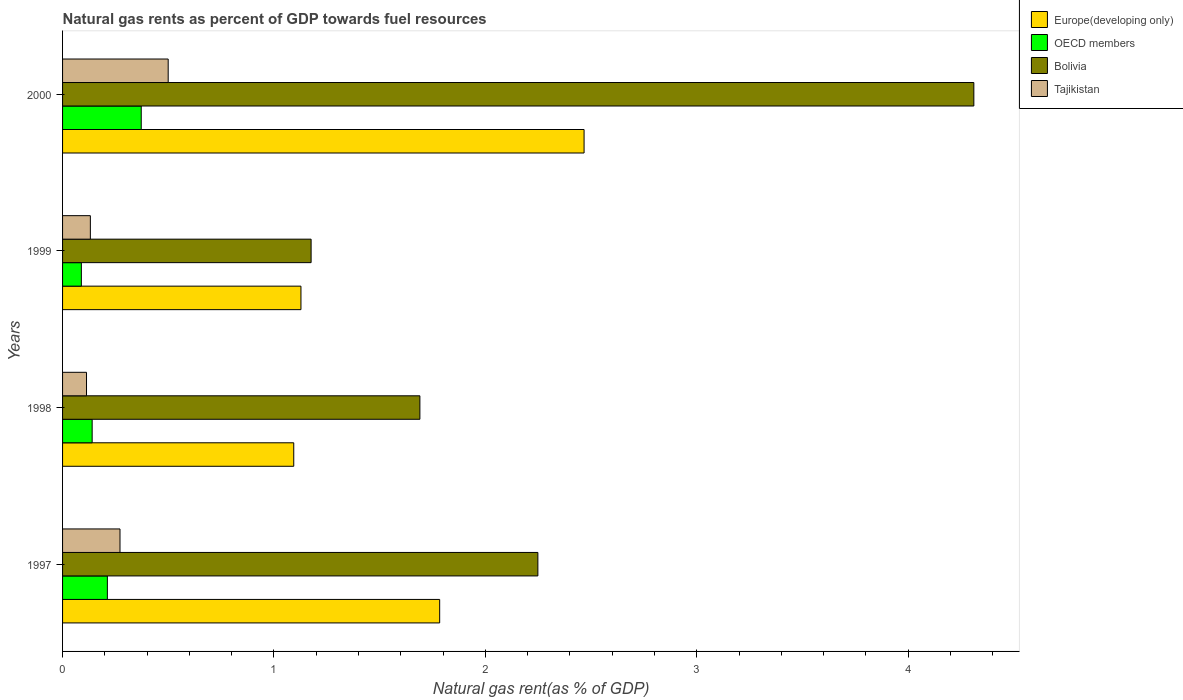How many bars are there on the 4th tick from the top?
Your answer should be compact. 4. What is the label of the 3rd group of bars from the top?
Your answer should be very brief. 1998. What is the natural gas rent in OECD members in 1999?
Keep it short and to the point. 0.09. Across all years, what is the maximum natural gas rent in Bolivia?
Offer a very short reply. 4.31. Across all years, what is the minimum natural gas rent in Bolivia?
Your response must be concise. 1.18. In which year was the natural gas rent in Europe(developing only) maximum?
Offer a terse response. 2000. In which year was the natural gas rent in Europe(developing only) minimum?
Provide a succinct answer. 1998. What is the total natural gas rent in OECD members in the graph?
Provide a succinct answer. 0.81. What is the difference between the natural gas rent in Tajikistan in 1998 and that in 2000?
Offer a very short reply. -0.39. What is the difference between the natural gas rent in Bolivia in 1998 and the natural gas rent in Europe(developing only) in 1999?
Make the answer very short. 0.56. What is the average natural gas rent in OECD members per year?
Your answer should be very brief. 0.2. In the year 1998, what is the difference between the natural gas rent in Europe(developing only) and natural gas rent in Tajikistan?
Offer a terse response. 0.98. In how many years, is the natural gas rent in Europe(developing only) greater than 3.2 %?
Give a very brief answer. 0. What is the ratio of the natural gas rent in Tajikistan in 1997 to that in 2000?
Provide a succinct answer. 0.54. Is the natural gas rent in Europe(developing only) in 1999 less than that in 2000?
Provide a short and direct response. Yes. Is the difference between the natural gas rent in Europe(developing only) in 1997 and 1999 greater than the difference between the natural gas rent in Tajikistan in 1997 and 1999?
Your response must be concise. Yes. What is the difference between the highest and the second highest natural gas rent in Bolivia?
Provide a short and direct response. 2.06. What is the difference between the highest and the lowest natural gas rent in Tajikistan?
Make the answer very short. 0.39. Is the sum of the natural gas rent in OECD members in 1997 and 2000 greater than the maximum natural gas rent in Europe(developing only) across all years?
Provide a succinct answer. No. What does the 4th bar from the top in 1999 represents?
Provide a short and direct response. Europe(developing only). What does the 4th bar from the bottom in 2000 represents?
Keep it short and to the point. Tajikistan. Are all the bars in the graph horizontal?
Make the answer very short. Yes. How many years are there in the graph?
Offer a terse response. 4. Does the graph contain grids?
Give a very brief answer. No. Where does the legend appear in the graph?
Your answer should be very brief. Top right. How many legend labels are there?
Offer a terse response. 4. What is the title of the graph?
Make the answer very short. Natural gas rents as percent of GDP towards fuel resources. Does "Spain" appear as one of the legend labels in the graph?
Your response must be concise. No. What is the label or title of the X-axis?
Offer a very short reply. Natural gas rent(as % of GDP). What is the Natural gas rent(as % of GDP) of Europe(developing only) in 1997?
Ensure brevity in your answer.  1.78. What is the Natural gas rent(as % of GDP) of OECD members in 1997?
Ensure brevity in your answer.  0.21. What is the Natural gas rent(as % of GDP) in Bolivia in 1997?
Offer a terse response. 2.25. What is the Natural gas rent(as % of GDP) of Tajikistan in 1997?
Your answer should be compact. 0.27. What is the Natural gas rent(as % of GDP) of Europe(developing only) in 1998?
Your response must be concise. 1.09. What is the Natural gas rent(as % of GDP) in OECD members in 1998?
Offer a terse response. 0.14. What is the Natural gas rent(as % of GDP) of Bolivia in 1998?
Offer a terse response. 1.69. What is the Natural gas rent(as % of GDP) in Tajikistan in 1998?
Give a very brief answer. 0.11. What is the Natural gas rent(as % of GDP) in Europe(developing only) in 1999?
Give a very brief answer. 1.13. What is the Natural gas rent(as % of GDP) of OECD members in 1999?
Provide a short and direct response. 0.09. What is the Natural gas rent(as % of GDP) in Bolivia in 1999?
Keep it short and to the point. 1.18. What is the Natural gas rent(as % of GDP) of Tajikistan in 1999?
Your response must be concise. 0.13. What is the Natural gas rent(as % of GDP) of Europe(developing only) in 2000?
Provide a succinct answer. 2.47. What is the Natural gas rent(as % of GDP) of OECD members in 2000?
Ensure brevity in your answer.  0.37. What is the Natural gas rent(as % of GDP) of Bolivia in 2000?
Provide a short and direct response. 4.31. What is the Natural gas rent(as % of GDP) in Tajikistan in 2000?
Keep it short and to the point. 0.5. Across all years, what is the maximum Natural gas rent(as % of GDP) in Europe(developing only)?
Ensure brevity in your answer.  2.47. Across all years, what is the maximum Natural gas rent(as % of GDP) in OECD members?
Provide a short and direct response. 0.37. Across all years, what is the maximum Natural gas rent(as % of GDP) of Bolivia?
Ensure brevity in your answer.  4.31. Across all years, what is the maximum Natural gas rent(as % of GDP) of Tajikistan?
Make the answer very short. 0.5. Across all years, what is the minimum Natural gas rent(as % of GDP) of Europe(developing only)?
Your answer should be very brief. 1.09. Across all years, what is the minimum Natural gas rent(as % of GDP) of OECD members?
Provide a short and direct response. 0.09. Across all years, what is the minimum Natural gas rent(as % of GDP) of Bolivia?
Your answer should be compact. 1.18. Across all years, what is the minimum Natural gas rent(as % of GDP) in Tajikistan?
Ensure brevity in your answer.  0.11. What is the total Natural gas rent(as % of GDP) in Europe(developing only) in the graph?
Keep it short and to the point. 6.47. What is the total Natural gas rent(as % of GDP) in OECD members in the graph?
Make the answer very short. 0.81. What is the total Natural gas rent(as % of GDP) of Bolivia in the graph?
Ensure brevity in your answer.  9.42. What is the total Natural gas rent(as % of GDP) of Tajikistan in the graph?
Give a very brief answer. 1.02. What is the difference between the Natural gas rent(as % of GDP) of Europe(developing only) in 1997 and that in 1998?
Offer a terse response. 0.69. What is the difference between the Natural gas rent(as % of GDP) of OECD members in 1997 and that in 1998?
Offer a very short reply. 0.07. What is the difference between the Natural gas rent(as % of GDP) in Bolivia in 1997 and that in 1998?
Provide a short and direct response. 0.56. What is the difference between the Natural gas rent(as % of GDP) in Tajikistan in 1997 and that in 1998?
Provide a short and direct response. 0.16. What is the difference between the Natural gas rent(as % of GDP) in Europe(developing only) in 1997 and that in 1999?
Provide a succinct answer. 0.66. What is the difference between the Natural gas rent(as % of GDP) of OECD members in 1997 and that in 1999?
Ensure brevity in your answer.  0.12. What is the difference between the Natural gas rent(as % of GDP) in Bolivia in 1997 and that in 1999?
Make the answer very short. 1.07. What is the difference between the Natural gas rent(as % of GDP) of Tajikistan in 1997 and that in 1999?
Offer a terse response. 0.14. What is the difference between the Natural gas rent(as % of GDP) of Europe(developing only) in 1997 and that in 2000?
Your answer should be compact. -0.68. What is the difference between the Natural gas rent(as % of GDP) of OECD members in 1997 and that in 2000?
Provide a short and direct response. -0.16. What is the difference between the Natural gas rent(as % of GDP) of Bolivia in 1997 and that in 2000?
Your answer should be compact. -2.06. What is the difference between the Natural gas rent(as % of GDP) in Tajikistan in 1997 and that in 2000?
Keep it short and to the point. -0.23. What is the difference between the Natural gas rent(as % of GDP) in Europe(developing only) in 1998 and that in 1999?
Provide a succinct answer. -0.03. What is the difference between the Natural gas rent(as % of GDP) in OECD members in 1998 and that in 1999?
Offer a very short reply. 0.05. What is the difference between the Natural gas rent(as % of GDP) in Bolivia in 1998 and that in 1999?
Offer a very short reply. 0.51. What is the difference between the Natural gas rent(as % of GDP) in Tajikistan in 1998 and that in 1999?
Your response must be concise. -0.02. What is the difference between the Natural gas rent(as % of GDP) in Europe(developing only) in 1998 and that in 2000?
Provide a succinct answer. -1.37. What is the difference between the Natural gas rent(as % of GDP) in OECD members in 1998 and that in 2000?
Your answer should be very brief. -0.23. What is the difference between the Natural gas rent(as % of GDP) in Bolivia in 1998 and that in 2000?
Your answer should be compact. -2.62. What is the difference between the Natural gas rent(as % of GDP) in Tajikistan in 1998 and that in 2000?
Your answer should be compact. -0.39. What is the difference between the Natural gas rent(as % of GDP) of Europe(developing only) in 1999 and that in 2000?
Offer a very short reply. -1.34. What is the difference between the Natural gas rent(as % of GDP) of OECD members in 1999 and that in 2000?
Offer a very short reply. -0.28. What is the difference between the Natural gas rent(as % of GDP) of Bolivia in 1999 and that in 2000?
Your answer should be very brief. -3.13. What is the difference between the Natural gas rent(as % of GDP) in Tajikistan in 1999 and that in 2000?
Offer a very short reply. -0.37. What is the difference between the Natural gas rent(as % of GDP) of Europe(developing only) in 1997 and the Natural gas rent(as % of GDP) of OECD members in 1998?
Your answer should be very brief. 1.64. What is the difference between the Natural gas rent(as % of GDP) of Europe(developing only) in 1997 and the Natural gas rent(as % of GDP) of Bolivia in 1998?
Make the answer very short. 0.09. What is the difference between the Natural gas rent(as % of GDP) in Europe(developing only) in 1997 and the Natural gas rent(as % of GDP) in Tajikistan in 1998?
Your answer should be very brief. 1.67. What is the difference between the Natural gas rent(as % of GDP) in OECD members in 1997 and the Natural gas rent(as % of GDP) in Bolivia in 1998?
Ensure brevity in your answer.  -1.48. What is the difference between the Natural gas rent(as % of GDP) in OECD members in 1997 and the Natural gas rent(as % of GDP) in Tajikistan in 1998?
Your response must be concise. 0.1. What is the difference between the Natural gas rent(as % of GDP) of Bolivia in 1997 and the Natural gas rent(as % of GDP) of Tajikistan in 1998?
Keep it short and to the point. 2.14. What is the difference between the Natural gas rent(as % of GDP) in Europe(developing only) in 1997 and the Natural gas rent(as % of GDP) in OECD members in 1999?
Offer a terse response. 1.7. What is the difference between the Natural gas rent(as % of GDP) of Europe(developing only) in 1997 and the Natural gas rent(as % of GDP) of Bolivia in 1999?
Keep it short and to the point. 0.61. What is the difference between the Natural gas rent(as % of GDP) in Europe(developing only) in 1997 and the Natural gas rent(as % of GDP) in Tajikistan in 1999?
Give a very brief answer. 1.65. What is the difference between the Natural gas rent(as % of GDP) of OECD members in 1997 and the Natural gas rent(as % of GDP) of Bolivia in 1999?
Your answer should be compact. -0.96. What is the difference between the Natural gas rent(as % of GDP) in OECD members in 1997 and the Natural gas rent(as % of GDP) in Tajikistan in 1999?
Keep it short and to the point. 0.08. What is the difference between the Natural gas rent(as % of GDP) in Bolivia in 1997 and the Natural gas rent(as % of GDP) in Tajikistan in 1999?
Your response must be concise. 2.12. What is the difference between the Natural gas rent(as % of GDP) of Europe(developing only) in 1997 and the Natural gas rent(as % of GDP) of OECD members in 2000?
Ensure brevity in your answer.  1.41. What is the difference between the Natural gas rent(as % of GDP) in Europe(developing only) in 1997 and the Natural gas rent(as % of GDP) in Bolivia in 2000?
Provide a succinct answer. -2.53. What is the difference between the Natural gas rent(as % of GDP) of Europe(developing only) in 1997 and the Natural gas rent(as % of GDP) of Tajikistan in 2000?
Your response must be concise. 1.28. What is the difference between the Natural gas rent(as % of GDP) of OECD members in 1997 and the Natural gas rent(as % of GDP) of Bolivia in 2000?
Provide a short and direct response. -4.1. What is the difference between the Natural gas rent(as % of GDP) of OECD members in 1997 and the Natural gas rent(as % of GDP) of Tajikistan in 2000?
Provide a short and direct response. -0.29. What is the difference between the Natural gas rent(as % of GDP) in Bolivia in 1997 and the Natural gas rent(as % of GDP) in Tajikistan in 2000?
Give a very brief answer. 1.75. What is the difference between the Natural gas rent(as % of GDP) in Europe(developing only) in 1998 and the Natural gas rent(as % of GDP) in OECD members in 1999?
Your answer should be very brief. 1. What is the difference between the Natural gas rent(as % of GDP) of Europe(developing only) in 1998 and the Natural gas rent(as % of GDP) of Bolivia in 1999?
Give a very brief answer. -0.08. What is the difference between the Natural gas rent(as % of GDP) in Europe(developing only) in 1998 and the Natural gas rent(as % of GDP) in Tajikistan in 1999?
Keep it short and to the point. 0.96. What is the difference between the Natural gas rent(as % of GDP) in OECD members in 1998 and the Natural gas rent(as % of GDP) in Bolivia in 1999?
Your response must be concise. -1.04. What is the difference between the Natural gas rent(as % of GDP) of OECD members in 1998 and the Natural gas rent(as % of GDP) of Tajikistan in 1999?
Provide a short and direct response. 0.01. What is the difference between the Natural gas rent(as % of GDP) of Bolivia in 1998 and the Natural gas rent(as % of GDP) of Tajikistan in 1999?
Your response must be concise. 1.56. What is the difference between the Natural gas rent(as % of GDP) in Europe(developing only) in 1998 and the Natural gas rent(as % of GDP) in OECD members in 2000?
Offer a terse response. 0.72. What is the difference between the Natural gas rent(as % of GDP) in Europe(developing only) in 1998 and the Natural gas rent(as % of GDP) in Bolivia in 2000?
Your response must be concise. -3.22. What is the difference between the Natural gas rent(as % of GDP) in Europe(developing only) in 1998 and the Natural gas rent(as % of GDP) in Tajikistan in 2000?
Give a very brief answer. 0.59. What is the difference between the Natural gas rent(as % of GDP) of OECD members in 1998 and the Natural gas rent(as % of GDP) of Bolivia in 2000?
Ensure brevity in your answer.  -4.17. What is the difference between the Natural gas rent(as % of GDP) in OECD members in 1998 and the Natural gas rent(as % of GDP) in Tajikistan in 2000?
Provide a short and direct response. -0.36. What is the difference between the Natural gas rent(as % of GDP) in Bolivia in 1998 and the Natural gas rent(as % of GDP) in Tajikistan in 2000?
Offer a very short reply. 1.19. What is the difference between the Natural gas rent(as % of GDP) in Europe(developing only) in 1999 and the Natural gas rent(as % of GDP) in OECD members in 2000?
Offer a very short reply. 0.76. What is the difference between the Natural gas rent(as % of GDP) of Europe(developing only) in 1999 and the Natural gas rent(as % of GDP) of Bolivia in 2000?
Offer a terse response. -3.18. What is the difference between the Natural gas rent(as % of GDP) of Europe(developing only) in 1999 and the Natural gas rent(as % of GDP) of Tajikistan in 2000?
Offer a very short reply. 0.63. What is the difference between the Natural gas rent(as % of GDP) of OECD members in 1999 and the Natural gas rent(as % of GDP) of Bolivia in 2000?
Offer a very short reply. -4.22. What is the difference between the Natural gas rent(as % of GDP) of OECD members in 1999 and the Natural gas rent(as % of GDP) of Tajikistan in 2000?
Provide a short and direct response. -0.41. What is the difference between the Natural gas rent(as % of GDP) in Bolivia in 1999 and the Natural gas rent(as % of GDP) in Tajikistan in 2000?
Provide a succinct answer. 0.68. What is the average Natural gas rent(as % of GDP) in Europe(developing only) per year?
Keep it short and to the point. 1.62. What is the average Natural gas rent(as % of GDP) in OECD members per year?
Keep it short and to the point. 0.2. What is the average Natural gas rent(as % of GDP) of Bolivia per year?
Your answer should be compact. 2.36. What is the average Natural gas rent(as % of GDP) of Tajikistan per year?
Provide a short and direct response. 0.25. In the year 1997, what is the difference between the Natural gas rent(as % of GDP) of Europe(developing only) and Natural gas rent(as % of GDP) of OECD members?
Make the answer very short. 1.57. In the year 1997, what is the difference between the Natural gas rent(as % of GDP) in Europe(developing only) and Natural gas rent(as % of GDP) in Bolivia?
Your answer should be compact. -0.46. In the year 1997, what is the difference between the Natural gas rent(as % of GDP) in Europe(developing only) and Natural gas rent(as % of GDP) in Tajikistan?
Make the answer very short. 1.51. In the year 1997, what is the difference between the Natural gas rent(as % of GDP) of OECD members and Natural gas rent(as % of GDP) of Bolivia?
Your answer should be very brief. -2.04. In the year 1997, what is the difference between the Natural gas rent(as % of GDP) in OECD members and Natural gas rent(as % of GDP) in Tajikistan?
Your answer should be compact. -0.06. In the year 1997, what is the difference between the Natural gas rent(as % of GDP) in Bolivia and Natural gas rent(as % of GDP) in Tajikistan?
Give a very brief answer. 1.98. In the year 1998, what is the difference between the Natural gas rent(as % of GDP) in Europe(developing only) and Natural gas rent(as % of GDP) in OECD members?
Offer a terse response. 0.95. In the year 1998, what is the difference between the Natural gas rent(as % of GDP) in Europe(developing only) and Natural gas rent(as % of GDP) in Bolivia?
Your answer should be compact. -0.6. In the year 1998, what is the difference between the Natural gas rent(as % of GDP) of Europe(developing only) and Natural gas rent(as % of GDP) of Tajikistan?
Offer a terse response. 0.98. In the year 1998, what is the difference between the Natural gas rent(as % of GDP) of OECD members and Natural gas rent(as % of GDP) of Bolivia?
Offer a terse response. -1.55. In the year 1998, what is the difference between the Natural gas rent(as % of GDP) in OECD members and Natural gas rent(as % of GDP) in Tajikistan?
Your answer should be very brief. 0.03. In the year 1998, what is the difference between the Natural gas rent(as % of GDP) of Bolivia and Natural gas rent(as % of GDP) of Tajikistan?
Your answer should be very brief. 1.58. In the year 1999, what is the difference between the Natural gas rent(as % of GDP) in Europe(developing only) and Natural gas rent(as % of GDP) in OECD members?
Provide a succinct answer. 1.04. In the year 1999, what is the difference between the Natural gas rent(as % of GDP) of Europe(developing only) and Natural gas rent(as % of GDP) of Bolivia?
Offer a terse response. -0.05. In the year 1999, what is the difference between the Natural gas rent(as % of GDP) of Europe(developing only) and Natural gas rent(as % of GDP) of Tajikistan?
Ensure brevity in your answer.  1. In the year 1999, what is the difference between the Natural gas rent(as % of GDP) of OECD members and Natural gas rent(as % of GDP) of Bolivia?
Keep it short and to the point. -1.09. In the year 1999, what is the difference between the Natural gas rent(as % of GDP) of OECD members and Natural gas rent(as % of GDP) of Tajikistan?
Give a very brief answer. -0.04. In the year 1999, what is the difference between the Natural gas rent(as % of GDP) in Bolivia and Natural gas rent(as % of GDP) in Tajikistan?
Your answer should be compact. 1.04. In the year 2000, what is the difference between the Natural gas rent(as % of GDP) in Europe(developing only) and Natural gas rent(as % of GDP) in OECD members?
Keep it short and to the point. 2.09. In the year 2000, what is the difference between the Natural gas rent(as % of GDP) in Europe(developing only) and Natural gas rent(as % of GDP) in Bolivia?
Provide a succinct answer. -1.84. In the year 2000, what is the difference between the Natural gas rent(as % of GDP) in Europe(developing only) and Natural gas rent(as % of GDP) in Tajikistan?
Your response must be concise. 1.97. In the year 2000, what is the difference between the Natural gas rent(as % of GDP) of OECD members and Natural gas rent(as % of GDP) of Bolivia?
Make the answer very short. -3.94. In the year 2000, what is the difference between the Natural gas rent(as % of GDP) in OECD members and Natural gas rent(as % of GDP) in Tajikistan?
Offer a terse response. -0.13. In the year 2000, what is the difference between the Natural gas rent(as % of GDP) in Bolivia and Natural gas rent(as % of GDP) in Tajikistan?
Your answer should be compact. 3.81. What is the ratio of the Natural gas rent(as % of GDP) of Europe(developing only) in 1997 to that in 1998?
Offer a terse response. 1.63. What is the ratio of the Natural gas rent(as % of GDP) in OECD members in 1997 to that in 1998?
Make the answer very short. 1.51. What is the ratio of the Natural gas rent(as % of GDP) of Bolivia in 1997 to that in 1998?
Your answer should be very brief. 1.33. What is the ratio of the Natural gas rent(as % of GDP) in Tajikistan in 1997 to that in 1998?
Offer a very short reply. 2.4. What is the ratio of the Natural gas rent(as % of GDP) of Europe(developing only) in 1997 to that in 1999?
Provide a short and direct response. 1.58. What is the ratio of the Natural gas rent(as % of GDP) in OECD members in 1997 to that in 1999?
Your answer should be compact. 2.38. What is the ratio of the Natural gas rent(as % of GDP) of Bolivia in 1997 to that in 1999?
Provide a short and direct response. 1.91. What is the ratio of the Natural gas rent(as % of GDP) in Tajikistan in 1997 to that in 1999?
Provide a succinct answer. 2.07. What is the ratio of the Natural gas rent(as % of GDP) in Europe(developing only) in 1997 to that in 2000?
Your response must be concise. 0.72. What is the ratio of the Natural gas rent(as % of GDP) in OECD members in 1997 to that in 2000?
Keep it short and to the point. 0.57. What is the ratio of the Natural gas rent(as % of GDP) of Bolivia in 1997 to that in 2000?
Your answer should be very brief. 0.52. What is the ratio of the Natural gas rent(as % of GDP) in Tajikistan in 1997 to that in 2000?
Offer a terse response. 0.54. What is the ratio of the Natural gas rent(as % of GDP) in Europe(developing only) in 1998 to that in 1999?
Your response must be concise. 0.97. What is the ratio of the Natural gas rent(as % of GDP) of OECD members in 1998 to that in 1999?
Give a very brief answer. 1.57. What is the ratio of the Natural gas rent(as % of GDP) of Bolivia in 1998 to that in 1999?
Ensure brevity in your answer.  1.44. What is the ratio of the Natural gas rent(as % of GDP) in Tajikistan in 1998 to that in 1999?
Keep it short and to the point. 0.86. What is the ratio of the Natural gas rent(as % of GDP) of Europe(developing only) in 1998 to that in 2000?
Make the answer very short. 0.44. What is the ratio of the Natural gas rent(as % of GDP) of OECD members in 1998 to that in 2000?
Offer a very short reply. 0.38. What is the ratio of the Natural gas rent(as % of GDP) of Bolivia in 1998 to that in 2000?
Offer a terse response. 0.39. What is the ratio of the Natural gas rent(as % of GDP) of Tajikistan in 1998 to that in 2000?
Ensure brevity in your answer.  0.23. What is the ratio of the Natural gas rent(as % of GDP) in Europe(developing only) in 1999 to that in 2000?
Offer a very short reply. 0.46. What is the ratio of the Natural gas rent(as % of GDP) in OECD members in 1999 to that in 2000?
Provide a succinct answer. 0.24. What is the ratio of the Natural gas rent(as % of GDP) of Bolivia in 1999 to that in 2000?
Your response must be concise. 0.27. What is the ratio of the Natural gas rent(as % of GDP) in Tajikistan in 1999 to that in 2000?
Your answer should be very brief. 0.26. What is the difference between the highest and the second highest Natural gas rent(as % of GDP) in Europe(developing only)?
Offer a terse response. 0.68. What is the difference between the highest and the second highest Natural gas rent(as % of GDP) of OECD members?
Give a very brief answer. 0.16. What is the difference between the highest and the second highest Natural gas rent(as % of GDP) of Bolivia?
Make the answer very short. 2.06. What is the difference between the highest and the second highest Natural gas rent(as % of GDP) in Tajikistan?
Provide a succinct answer. 0.23. What is the difference between the highest and the lowest Natural gas rent(as % of GDP) of Europe(developing only)?
Make the answer very short. 1.37. What is the difference between the highest and the lowest Natural gas rent(as % of GDP) of OECD members?
Make the answer very short. 0.28. What is the difference between the highest and the lowest Natural gas rent(as % of GDP) in Bolivia?
Provide a succinct answer. 3.13. What is the difference between the highest and the lowest Natural gas rent(as % of GDP) in Tajikistan?
Your answer should be very brief. 0.39. 